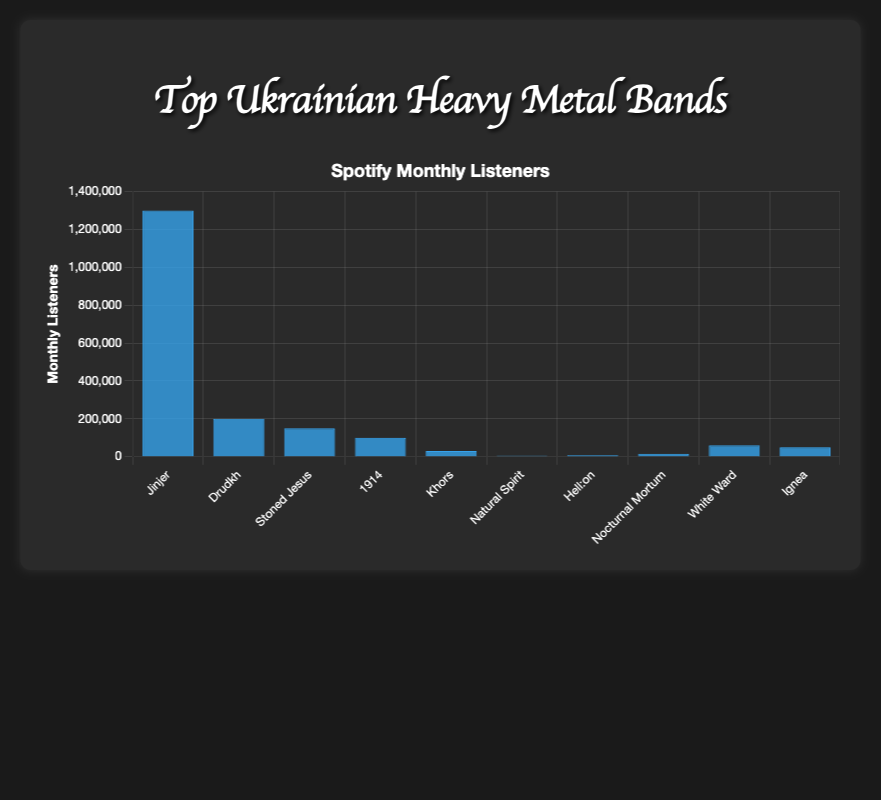Which band has the highest number of Spotify monthly listeners? By looking at the bar height in the chart, the tallest bar represents the band with the highest number of monthly listeners. "Jinjer" has the tallest bar indicating it has the highest listeners.
Answer: Jinjer Which band has fewer monthly listeners, "Stoned Jesus" or "1914"? Compare the bar heights of "Stoned Jesus" and "1914". The bar for "1914" is shorter than the bar for "Stoned Jesus", indicating "1914" has fewer listeners.
Answer: 1914 What is the total number of monthly listeners for the bands "Drudkh", "Khors", and "Ignea"? Sum the values for "Drudkh" (200,000), "Khors" (30,000), and "Ignea" (50,000). The calculation is 200,000 + 30,000 + 50,000 = 280,000.
Answer: 280,000 How many more monthly listeners does "Jinjer" have compared to "White Ward"? Subtract the number of listeners of "White Ward" (60,000) from "Jinjer" (1,300,000). So the calculation is 1,300,000 - 60,000 = 1,240,000.
Answer: 1,240,000 Which two bands have the smallest and the largest number of monthly listeners, respectively? The shortest bar indicates the smallest number of listeners, and the tallest bar indicates the largest. "Natural Spirit" has the smallest number with the shortest bar, and "Jinjer" has the largest number with the tallest bar.
Answer: Natural Spirit, Jinjer What is the average number of Spotify monthly listeners for all the bands? Calculate the sum of all listed monthly listeners: 1,300,000 + 200,000 + 150,000 + 100,000 + 30,000 + 5,000 + 8,000 + 15,000 + 60,000 + 50,000 = 1,918,000. Divide this by the number of bands (10). The average is 1,918,000 / 10 = 191,800.
Answer: 191,800 Which band has twice as many listeners as "Ignea"? "Ignea" has 50,000 listeners. Double this number to find 50,000 * 2 = 100,000. The band with 100,000 listeners is "1914".
Answer: 1914 